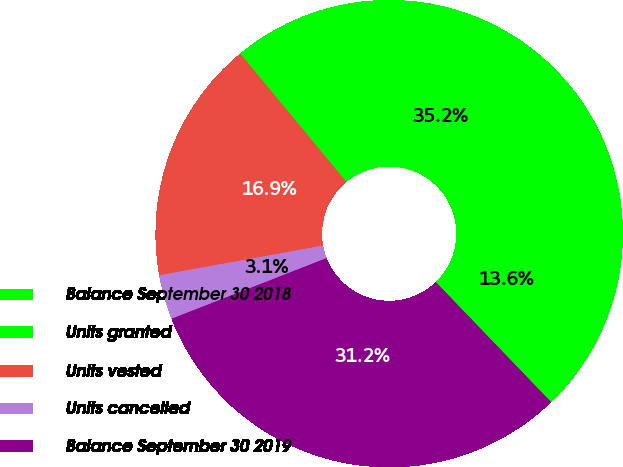Convert chart to OTSL. <chart><loc_0><loc_0><loc_500><loc_500><pie_chart><fcel>Balance September 30 2018<fcel>Units granted<fcel>Units vested<fcel>Units cancelled<fcel>Balance September 30 2019<nl><fcel>13.63%<fcel>35.19%<fcel>16.85%<fcel>3.08%<fcel>31.25%<nl></chart> 